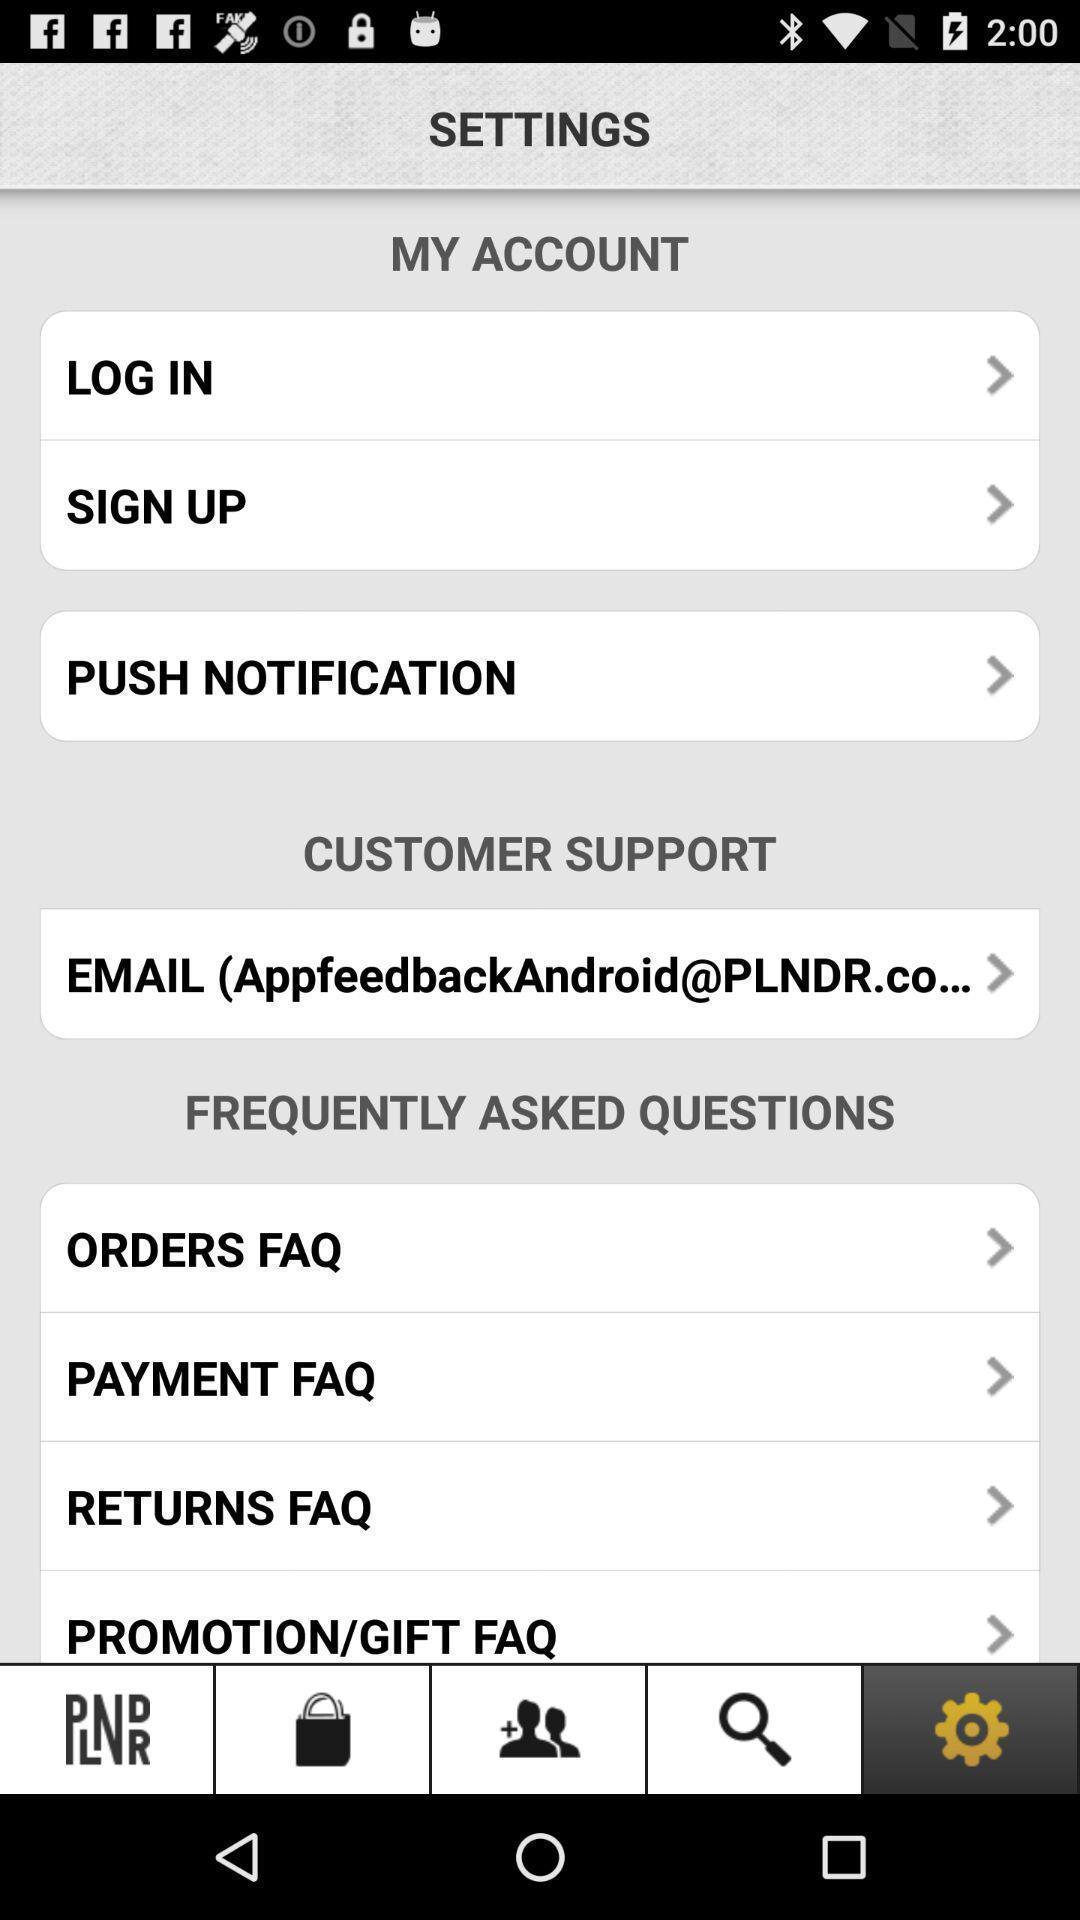Give me a narrative description of this picture. Settings page displaying account and other settings. 